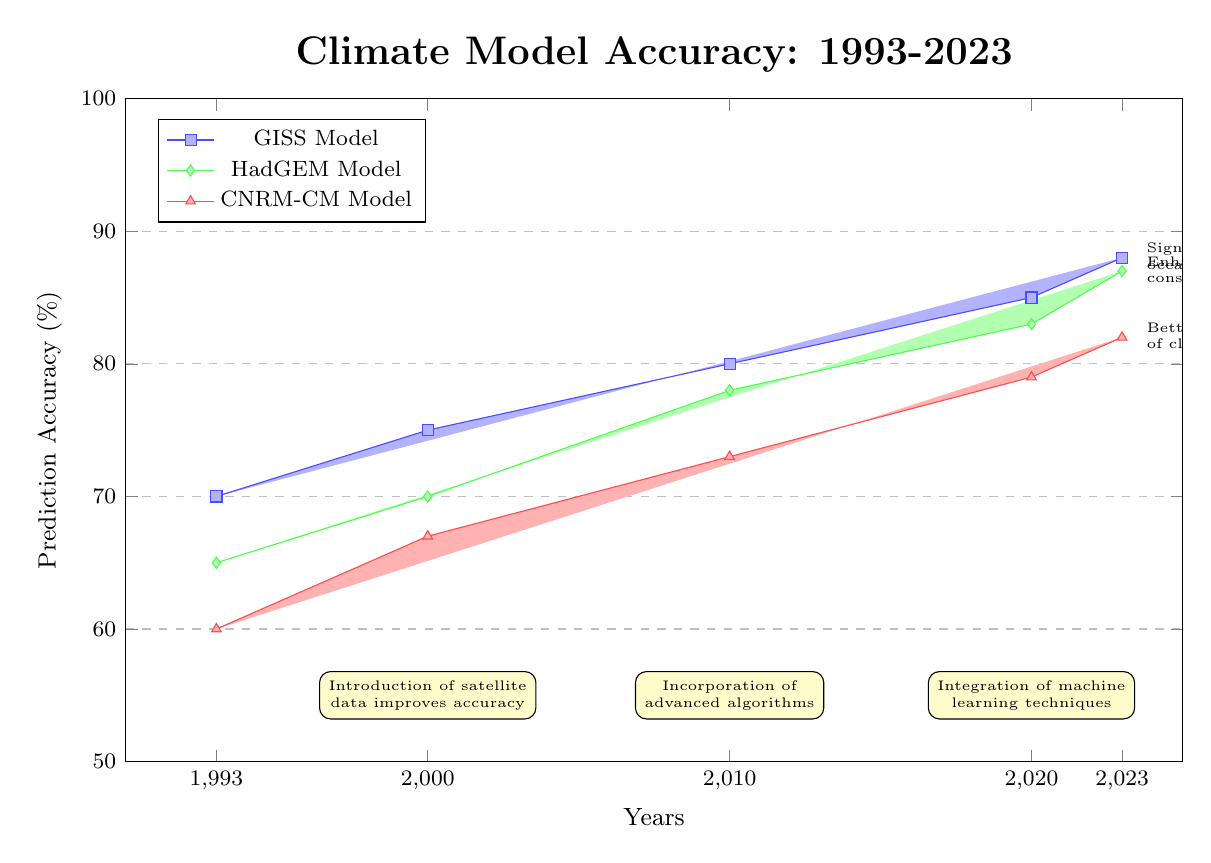What is the accuracy of the GISS Model in 2023? The GISS Model's accuracy in 2023 is directly indicated by the bar on the graph corresponding to that year, which shows a value of 88%.
Answer: 88% What was the accuracy of the CNRM-CM Model in 2010? The CNRM-CM Model's accuracy in 2010 is found by looking at the corresponding height of the bar for that model at the year 2010, which reaches 73%.
Answer: 73% Which model showed the highest accuracy improvement from 1993 to 2023? By comparing the accuracy values for each model from 1993 to 2023, we see that the GISS Model improved from 70% to 88%, resulting in the highest improvement of 18%.
Answer: GISS Model Which year had the lowest accuracy among the models presented? The year with the lowest accuracy is 1993, found by observing the heights of the bars across all three models, with the CNRM-CM Model at 60%.
Answer: 60% What notable advancements are highlighted for the GISS Model in recent years? The annotations next to the GISS Model indicate significant improvements in ocean-atmosphere coupling as a noteworthy advancement.
Answer: Ocean-atmosphere coupling How much did the prediction accuracy of the HadGEM Model increase from 2000 to 2023? To find the increase, subtract the 2000 accuracy of the HadGEM Model (70%) from its 2023 accuracy (87%), resulting in an increase of 17%.
Answer: 17% Which year marks the introduction of satellite data that improved accuracy? The introduction of satellite data, which is mentioned in the annotation, is noted to have occurred in the year 2000.
Answer: 2000 What annotations are present for the year 2020 regarding model improvements? The annotations for the year 2020 mention the integration of machine learning techniques as an improvement highlighted for that year.
Answer: Integration of machine learning techniques 